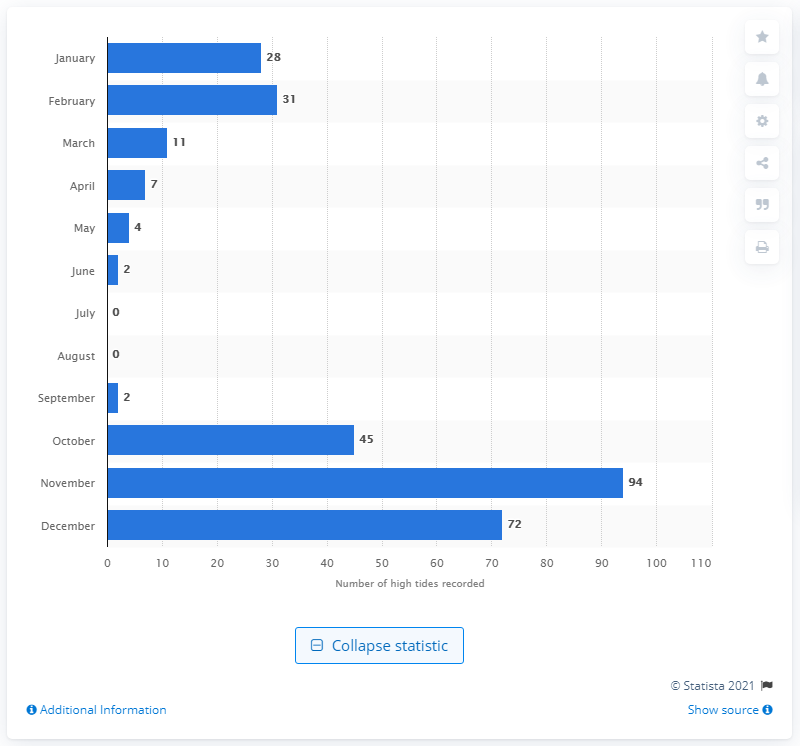Highlight a few significant elements in this photo. A total of 94 flood events occurred in Venice during the month of November. 